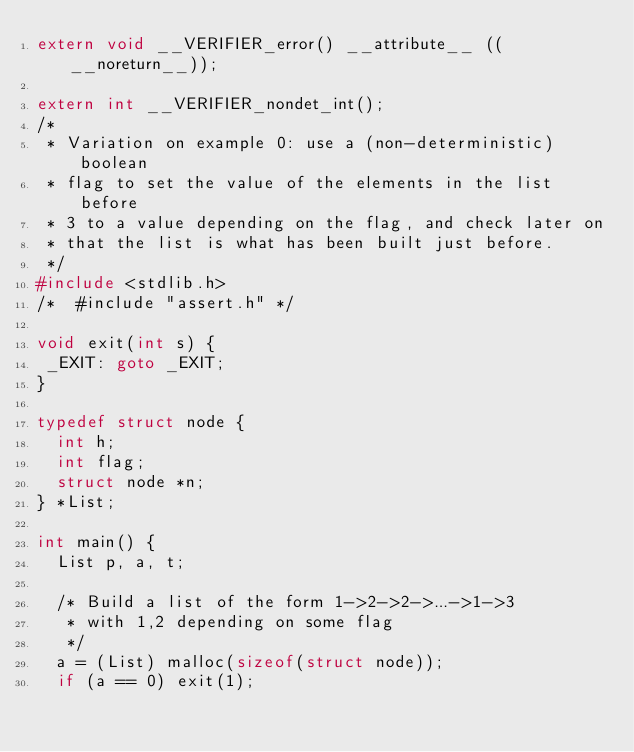Convert code to text. <code><loc_0><loc_0><loc_500><loc_500><_C_>extern void __VERIFIER_error() __attribute__ ((__noreturn__));

extern int __VERIFIER_nondet_int();
/*
 * Variation on example 0: use a (non-deterministic) boolean
 * flag to set the value of the elements in the list before
 * 3 to a value depending on the flag, and check later on
 * that the list is what has been built just before.
 */
#include <stdlib.h>
/*  #include "assert.h" */

void exit(int s) {
 _EXIT: goto _EXIT;
}

typedef struct node {
  int h;
  int flag;
  struct node *n;
} *List;

int main() {
  List p, a, t;

  /* Build a list of the form 1->2->2->...->1->3
   * with 1,2 depending on some flag
   */
  a = (List) malloc(sizeof(struct node));
  if (a == 0) exit(1);</code> 